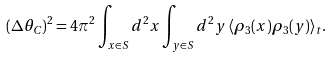<formula> <loc_0><loc_0><loc_500><loc_500>( \Delta \theta _ { C } ) ^ { 2 } = 4 \pi ^ { 2 } \int _ { { x } \in S } d ^ { 2 } x \int _ { { y } \in S } d ^ { 2 } y \, \langle \rho _ { 3 } ( { x } ) \rho _ { 3 } ( { y } ) \rangle _ { t } .</formula> 